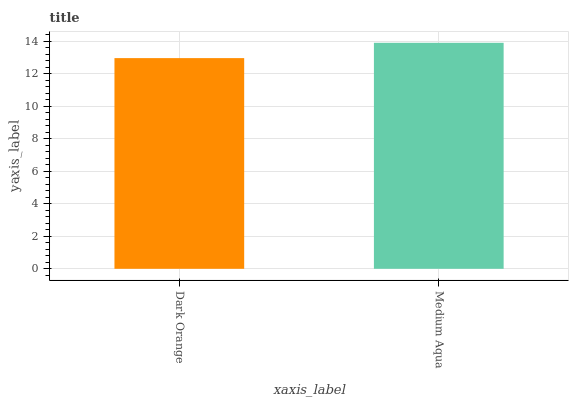Is Medium Aqua the minimum?
Answer yes or no. No. Is Medium Aqua greater than Dark Orange?
Answer yes or no. Yes. Is Dark Orange less than Medium Aqua?
Answer yes or no. Yes. Is Dark Orange greater than Medium Aqua?
Answer yes or no. No. Is Medium Aqua less than Dark Orange?
Answer yes or no. No. Is Medium Aqua the high median?
Answer yes or no. Yes. Is Dark Orange the low median?
Answer yes or no. Yes. Is Dark Orange the high median?
Answer yes or no. No. Is Medium Aqua the low median?
Answer yes or no. No. 